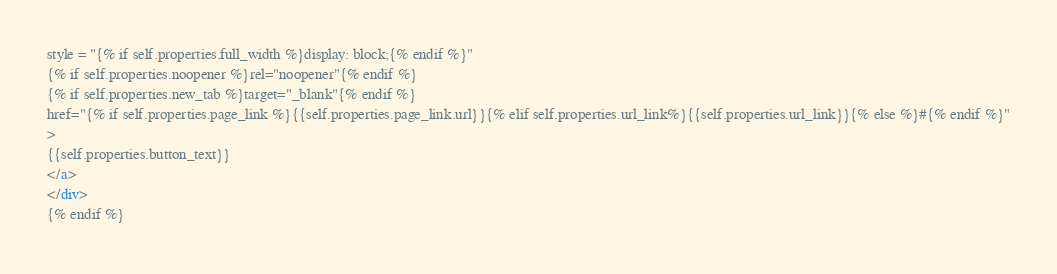<code> <loc_0><loc_0><loc_500><loc_500><_HTML_>style = "{% if self.properties.full_width %}display: block;{% endif %}"
{% if self.properties.noopener %}rel="noopener"{% endif %}
{% if self.properties.new_tab %}target="_blank"{% endif %}
href="{% if self.properties.page_link %}{{self.properties.page_link.url}}{% elif self.properties.url_link%}{{self.properties.url_link}}{% else %}#{% endif %}"
>
{{self.properties.button_text}}
</a>
</div>
{% endif %}</code> 